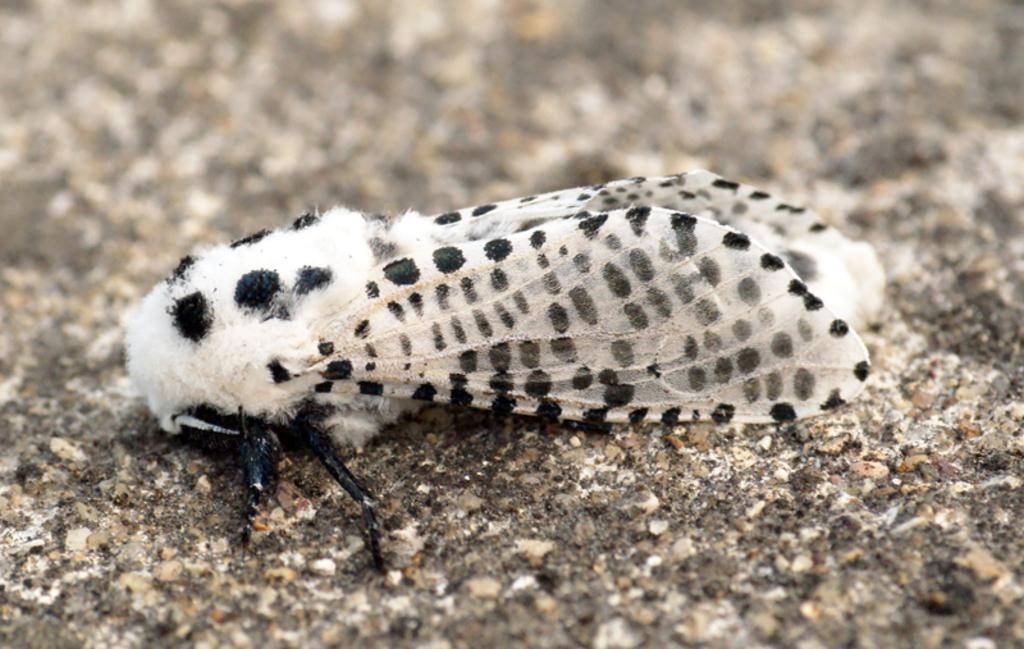What type of creature can be seen in the image? There is an insect in the image. What grade does the instrument receive in the image? There is no instrument present in the image, so it is not possible to determine a grade. 